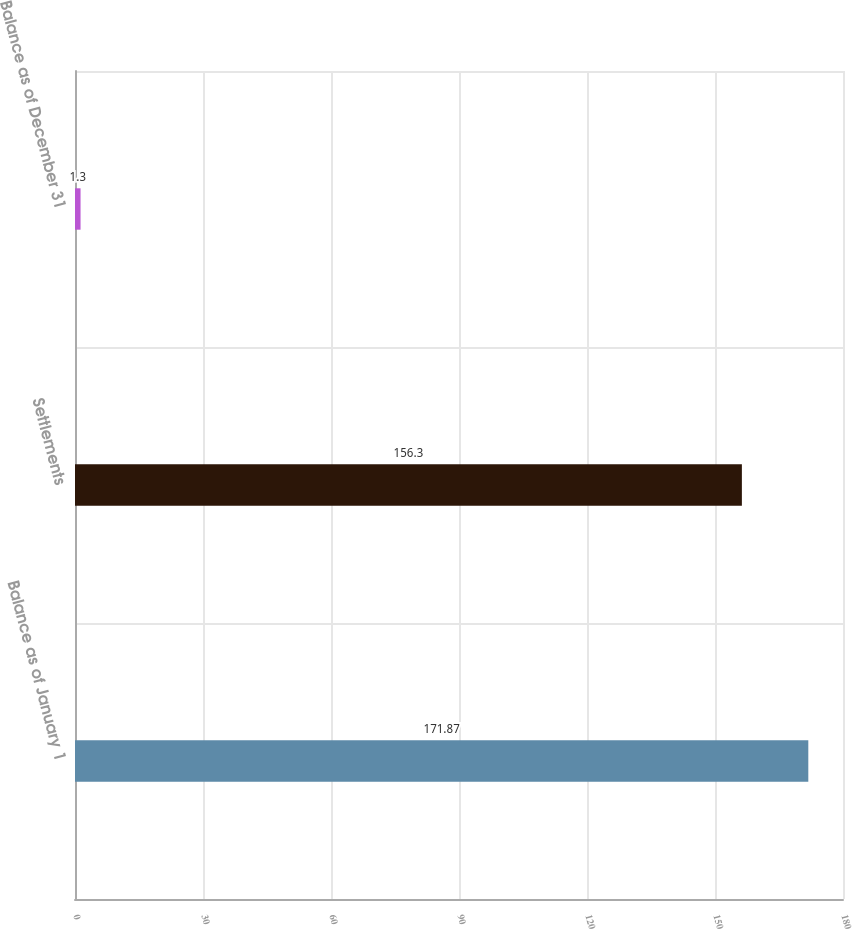Convert chart to OTSL. <chart><loc_0><loc_0><loc_500><loc_500><bar_chart><fcel>Balance as of January 1<fcel>Settlements<fcel>Balance as of December 31<nl><fcel>171.87<fcel>156.3<fcel>1.3<nl></chart> 